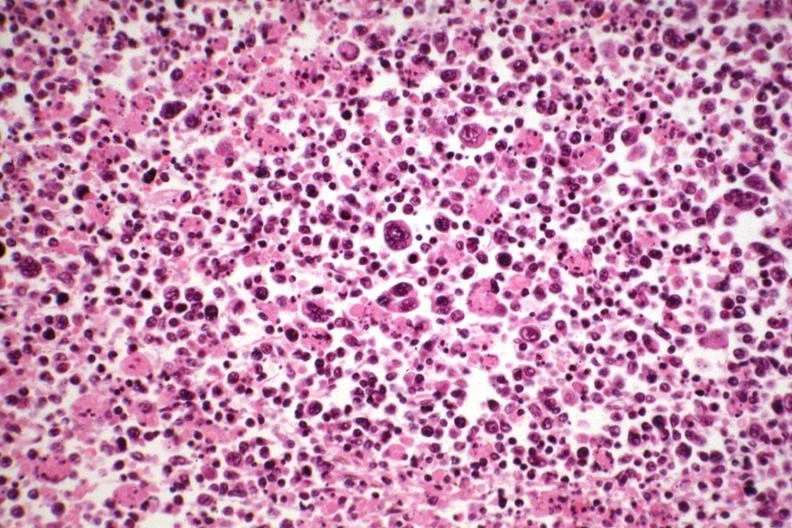what see other slides in file?
Answer the question using a single word or phrase. Hodgkins 